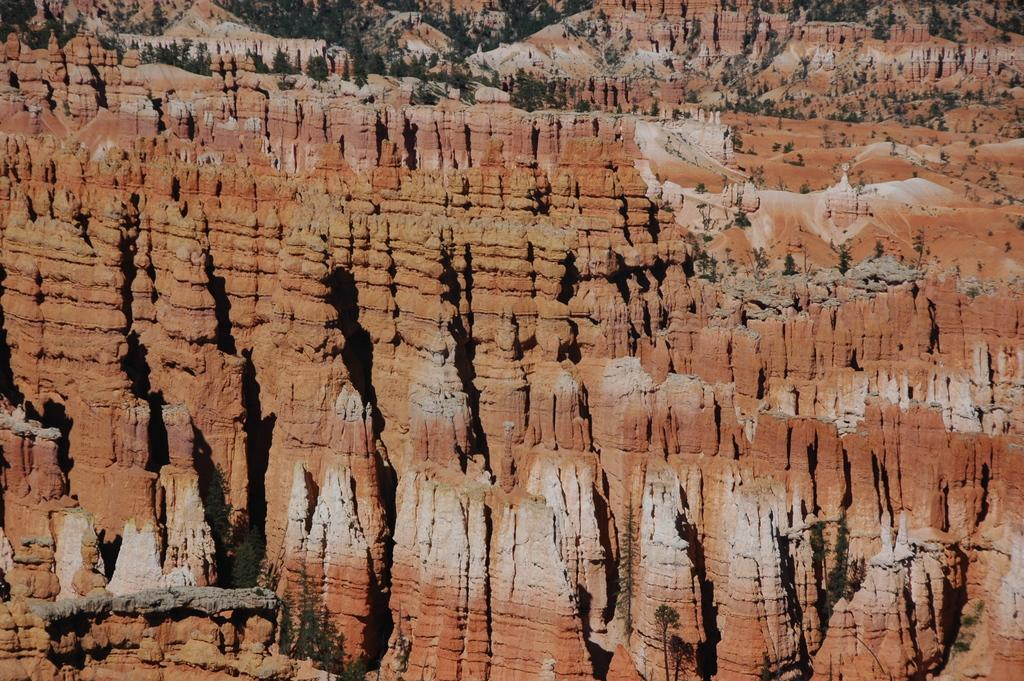What type of natural elements can be seen in the image? There are trees and rocks in the image. Can you describe the trees in the image? The trees in the image are likely part of a forest or wooded area. What other objects or features can be seen in the image? The only other element mentioned in the facts is rocks. What type of sponge is being used to clean the rocks in the image? There is no sponge present in the image, and no cleaning activity is depicted. 